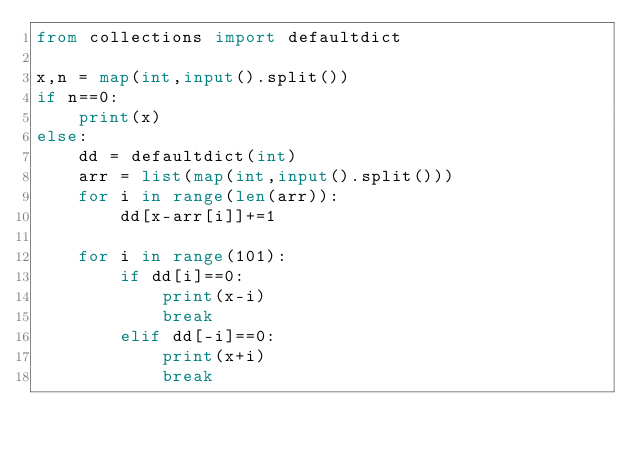<code> <loc_0><loc_0><loc_500><loc_500><_Python_>from collections import defaultdict

x,n = map(int,input().split())
if n==0:
    print(x)
else:
    dd = defaultdict(int)
    arr = list(map(int,input().split()))
    for i in range(len(arr)):
        dd[x-arr[i]]+=1

    for i in range(101):
        if dd[i]==0:
            print(x-i)
            break
        elif dd[-i]==0:
            print(x+i)
            break


</code> 